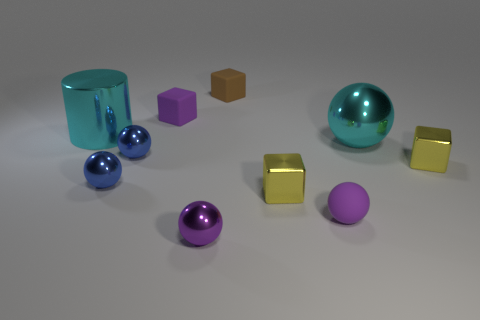There is a metal cylinder; does it have the same size as the purple matte object left of the tiny brown object?
Your response must be concise. No. Is there a small blue thing that is right of the cyan shiny object that is in front of the cyan cylinder?
Your response must be concise. No. There is a tiny purple matte thing that is to the right of the small brown rubber cube; what shape is it?
Keep it short and to the point. Sphere. There is a large cylinder that is the same color as the big metallic sphere; what is it made of?
Give a very brief answer. Metal. There is a small cube that is in front of the thing that is to the right of the big metal ball; what color is it?
Provide a short and direct response. Yellow. Do the purple block and the cyan metallic sphere have the same size?
Your answer should be very brief. No. What material is the purple object that is the same shape as the small brown object?
Give a very brief answer. Rubber. What number of matte balls have the same size as the brown block?
Keep it short and to the point. 1. There is another block that is made of the same material as the tiny brown cube; what is its color?
Provide a succinct answer. Purple. Is the number of large yellow metallic cubes less than the number of purple matte spheres?
Ensure brevity in your answer.  Yes. 